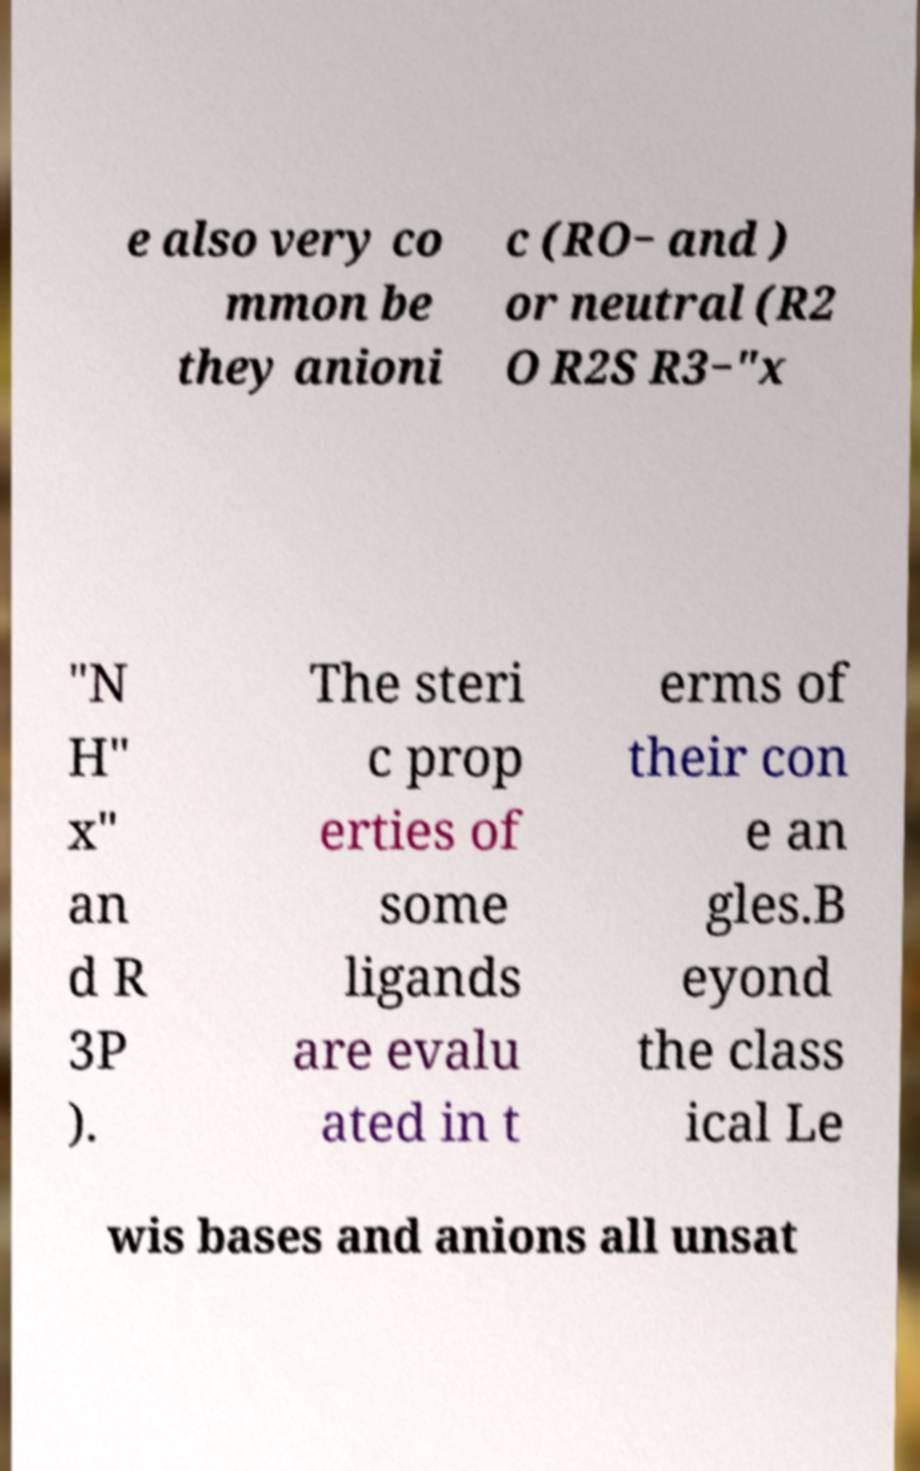Could you assist in decoding the text presented in this image and type it out clearly? e also very co mmon be they anioni c (RO− and ) or neutral (R2 O R2S R3−"x "N H" x" an d R 3P ). The steri c prop erties of some ligands are evalu ated in t erms of their con e an gles.B eyond the class ical Le wis bases and anions all unsat 